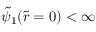<formula> <loc_0><loc_0><loc_500><loc_500>\tilde { \psi } _ { 1 } ( \tilde { r } = 0 ) < \infty</formula> 